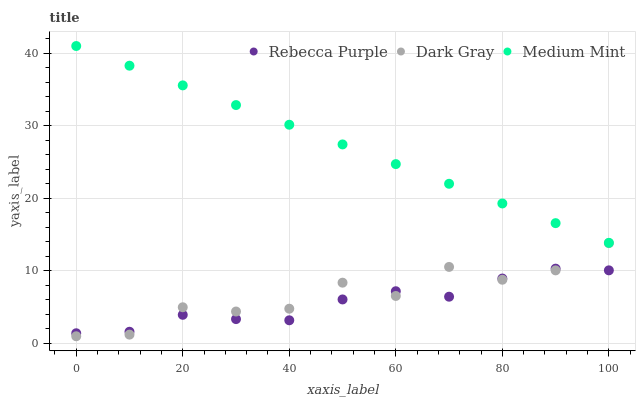Does Rebecca Purple have the minimum area under the curve?
Answer yes or no. Yes. Does Medium Mint have the maximum area under the curve?
Answer yes or no. Yes. Does Medium Mint have the minimum area under the curve?
Answer yes or no. No. Does Rebecca Purple have the maximum area under the curve?
Answer yes or no. No. Is Medium Mint the smoothest?
Answer yes or no. Yes. Is Dark Gray the roughest?
Answer yes or no. Yes. Is Rebecca Purple the smoothest?
Answer yes or no. No. Is Rebecca Purple the roughest?
Answer yes or no. No. Does Dark Gray have the lowest value?
Answer yes or no. Yes. Does Rebecca Purple have the lowest value?
Answer yes or no. No. Does Medium Mint have the highest value?
Answer yes or no. Yes. Does Rebecca Purple have the highest value?
Answer yes or no. No. Is Rebecca Purple less than Medium Mint?
Answer yes or no. Yes. Is Medium Mint greater than Dark Gray?
Answer yes or no. Yes. Does Dark Gray intersect Rebecca Purple?
Answer yes or no. Yes. Is Dark Gray less than Rebecca Purple?
Answer yes or no. No. Is Dark Gray greater than Rebecca Purple?
Answer yes or no. No. Does Rebecca Purple intersect Medium Mint?
Answer yes or no. No. 